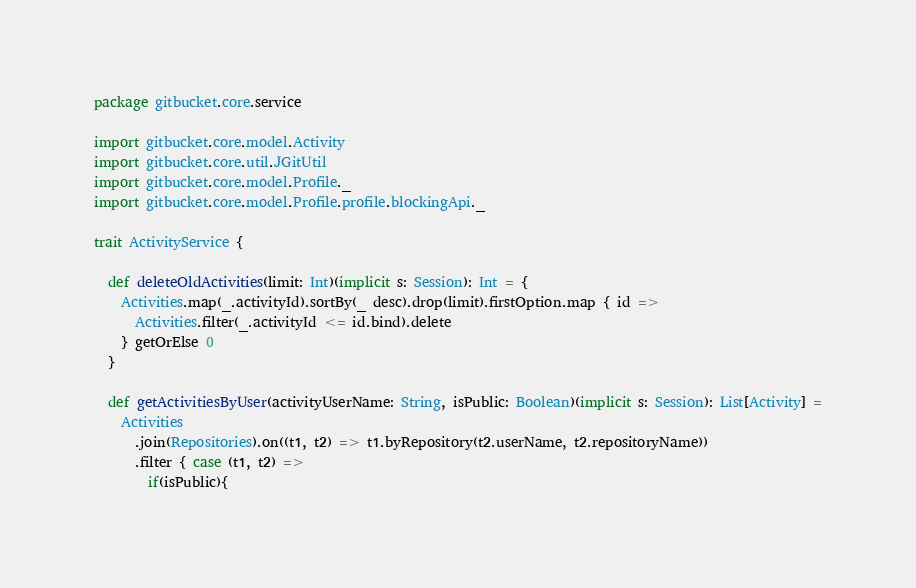Convert code to text. <code><loc_0><loc_0><loc_500><loc_500><_Scala_>package gitbucket.core.service

import gitbucket.core.model.Activity
import gitbucket.core.util.JGitUtil
import gitbucket.core.model.Profile._
import gitbucket.core.model.Profile.profile.blockingApi._

trait ActivityService {

  def deleteOldActivities(limit: Int)(implicit s: Session): Int = {
    Activities.map(_.activityId).sortBy(_ desc).drop(limit).firstOption.map { id =>
      Activities.filter(_.activityId <= id.bind).delete
    } getOrElse 0
  }

  def getActivitiesByUser(activityUserName: String, isPublic: Boolean)(implicit s: Session): List[Activity] =
    Activities
      .join(Repositories).on((t1, t2) => t1.byRepository(t2.userName, t2.repositoryName))
      .filter { case (t1, t2) =>
        if(isPublic){</code> 